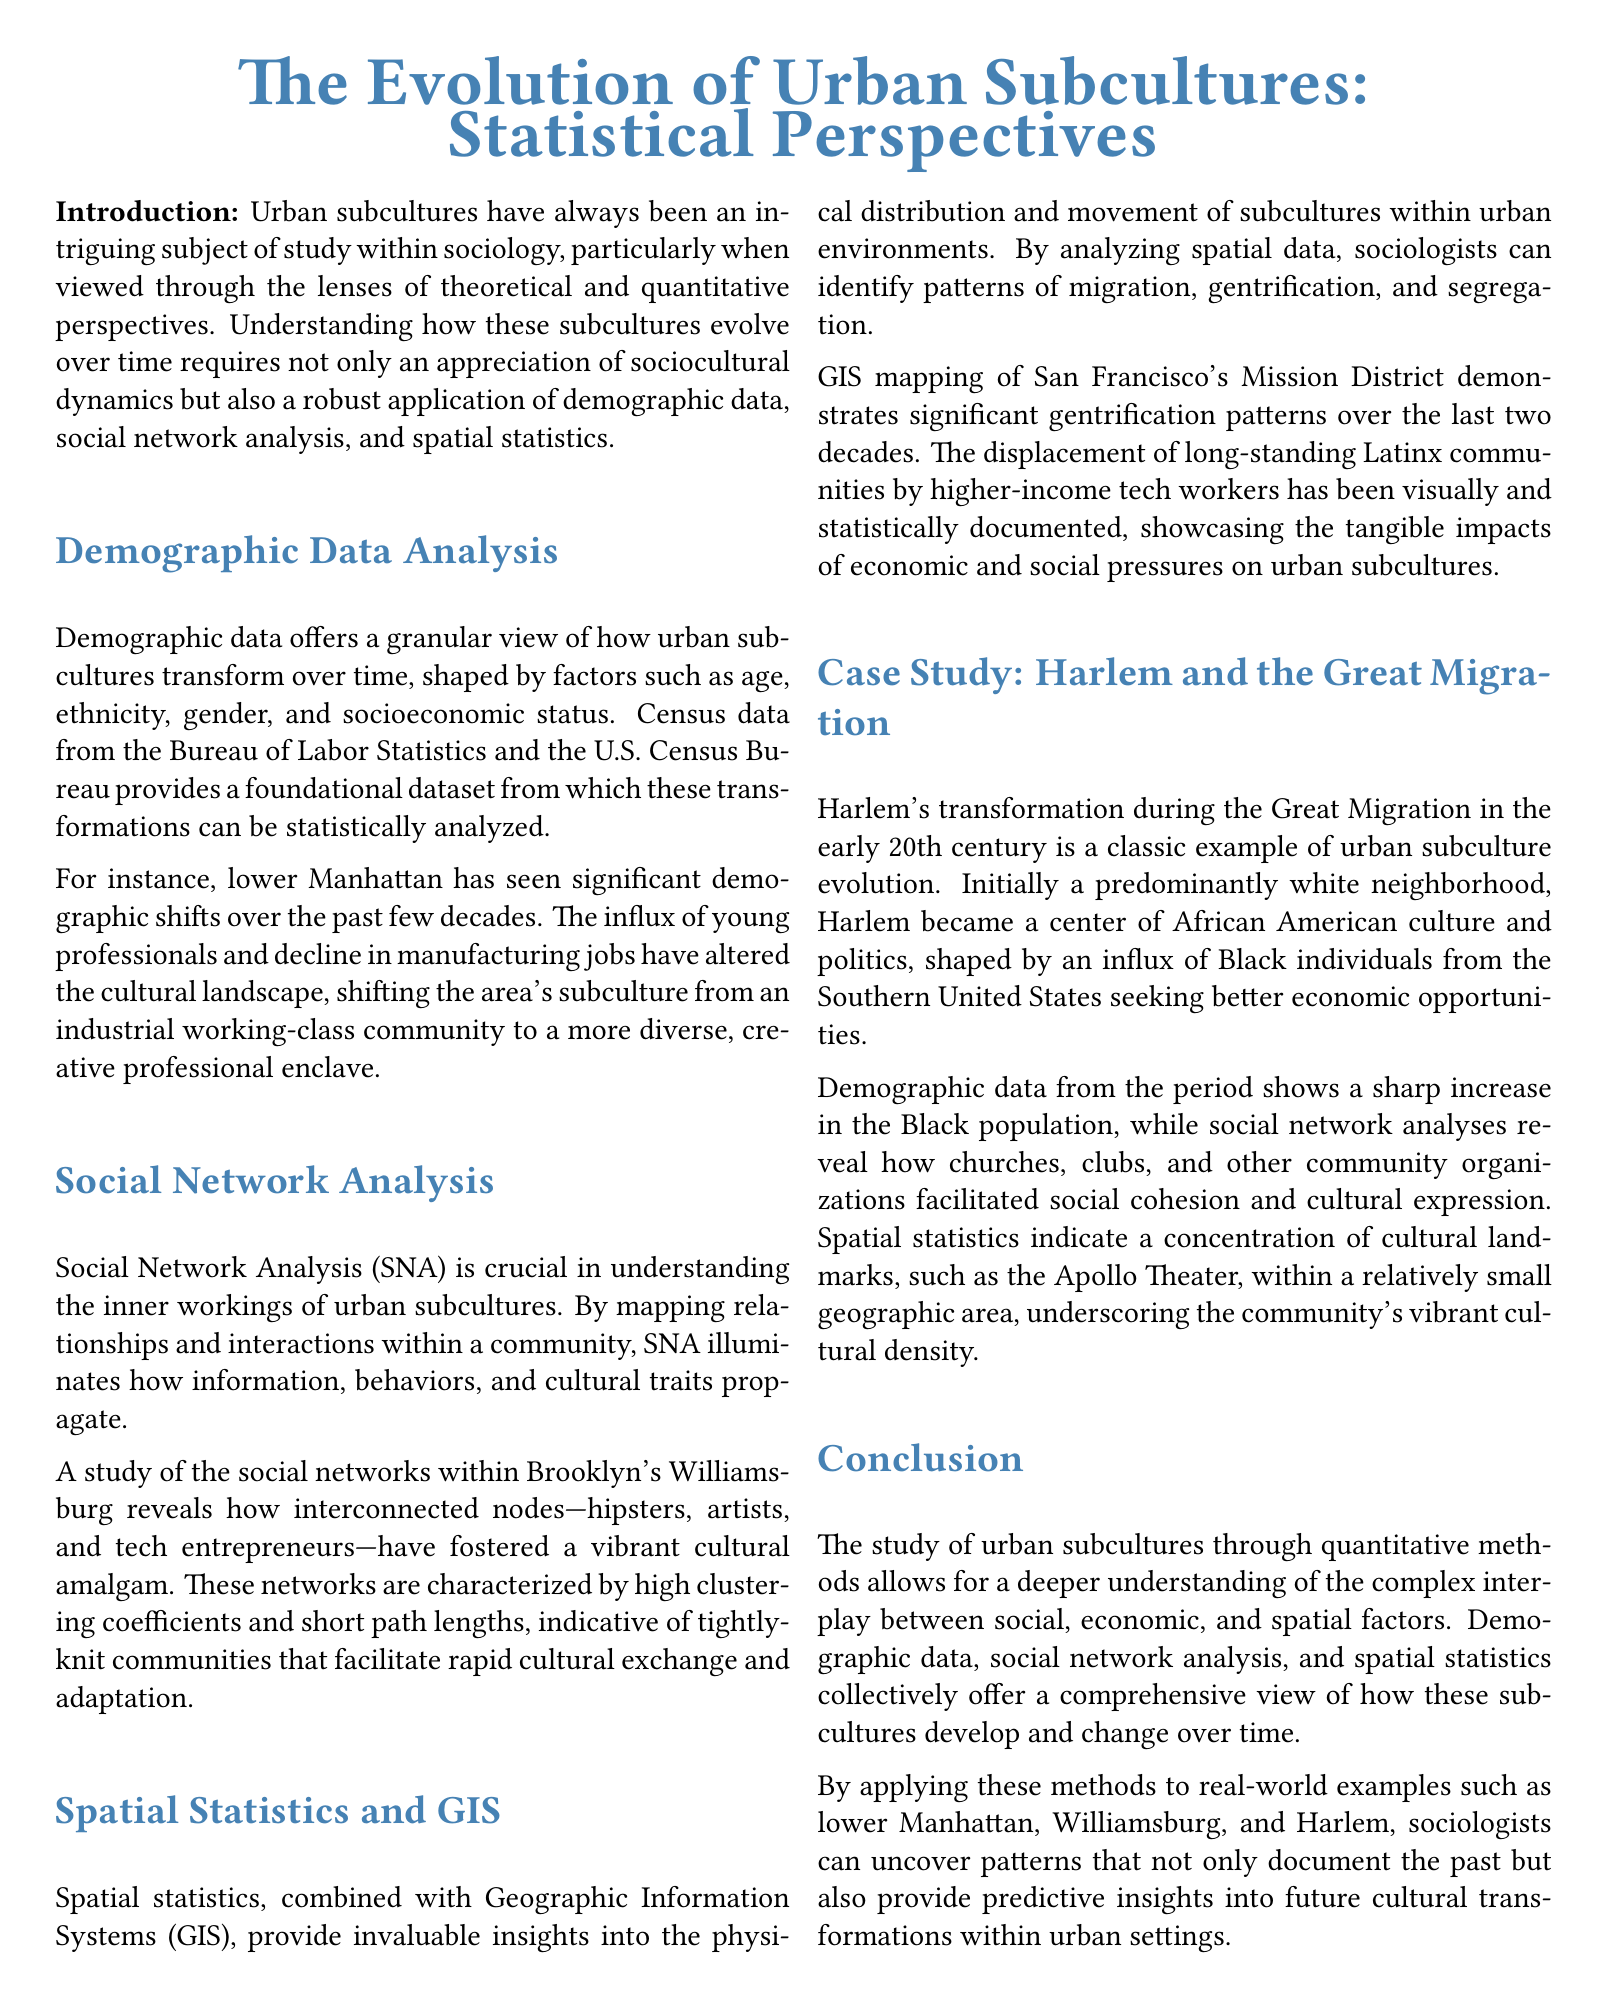What are the key lenses through which urban subcultures are studied? The key lenses include demographic data, social network analysis, and spatial statistics.
Answer: demographic data, social network analysis, spatial statistics What city is mentioned as having significant demographic shifts? Lower Manhattan is cited as an area with significant demographic shifts over the past few decades.
Answer: Lower Manhattan Which community is highlighted for its vibrant cultural amalgam? Williamsburg is discussed in the context of its vibrant cultural amalgam formed by interconnected nodes.
Answer: Williamsburg What major historical migration is analyzed in the document? The Great Migration is a significant historical migration analyzed for its impact on urban subculture evolution.
Answer: Great Migration What decade shows significant gentrification patterns in the Mission District? Over the last two decades significant gentrification patterns are documented in the Mission District.
Answer: last two decades What cultural landmark is specifically mentioned in the Harlem case study? The Apollo Theater is mentioned as a cultural landmark within Harlem's geographic area.
Answer: Apollo Theater What type of analysis reveals how relationships propagate within urban subcultures? Social Network Analysis (SNA) is the method used to understand how relationships propagate.
Answer: Social Network Analysis (SNA) What was the initial demographic composition of Harlem before the Great Migration? Harlem was initially a predominantly white neighborhood prior to the Great Migration.
Answer: predominantly white How does spatial statistics contribute to the study of urban subcultures? Spatial statistics help identify patterns of migration, gentrification, and segregation within urban environments.
Answer: patterns of migration, gentrification, and segregation What do tightly-knit communities facilitate according to the document? Tightly-knit communities facilitate rapid cultural exchange and adaptation.
Answer: rapid cultural exchange and adaptation 